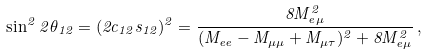<formula> <loc_0><loc_0><loc_500><loc_500>\sin ^ { 2 } 2 \theta _ { 1 2 } = ( 2 c _ { 1 2 } s _ { 1 2 } ) ^ { 2 } = \frac { 8 M _ { e \mu } ^ { 2 } } { ( M _ { e e } - M _ { \mu \mu } + M _ { \mu \tau } ) ^ { 2 } + 8 M _ { e \mu } ^ { 2 } } \, ,</formula> 